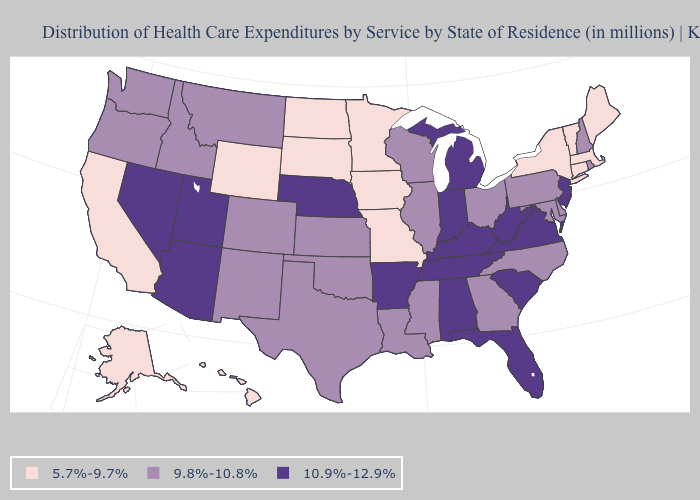What is the lowest value in states that border New Jersey?
Answer briefly. 5.7%-9.7%. Does Minnesota have the lowest value in the USA?
Write a very short answer. Yes. Which states have the lowest value in the USA?
Short answer required. Alaska, California, Connecticut, Hawaii, Iowa, Maine, Massachusetts, Minnesota, Missouri, New York, North Dakota, South Dakota, Vermont, Wyoming. What is the value of California?
Quick response, please. 5.7%-9.7%. Among the states that border New Mexico , which have the highest value?
Answer briefly. Arizona, Utah. Name the states that have a value in the range 10.9%-12.9%?
Quick response, please. Alabama, Arizona, Arkansas, Florida, Indiana, Kentucky, Michigan, Nebraska, Nevada, New Jersey, South Carolina, Tennessee, Utah, Virginia, West Virginia. Name the states that have a value in the range 5.7%-9.7%?
Answer briefly. Alaska, California, Connecticut, Hawaii, Iowa, Maine, Massachusetts, Minnesota, Missouri, New York, North Dakota, South Dakota, Vermont, Wyoming. Does Washington have the same value as Michigan?
Quick response, please. No. What is the value of Rhode Island?
Give a very brief answer. 9.8%-10.8%. What is the value of Georgia?
Short answer required. 9.8%-10.8%. What is the highest value in the MidWest ?
Be succinct. 10.9%-12.9%. What is the value of Wyoming?
Write a very short answer. 5.7%-9.7%. What is the value of Maine?
Short answer required. 5.7%-9.7%. Does the first symbol in the legend represent the smallest category?
Quick response, please. Yes. Name the states that have a value in the range 10.9%-12.9%?
Keep it brief. Alabama, Arizona, Arkansas, Florida, Indiana, Kentucky, Michigan, Nebraska, Nevada, New Jersey, South Carolina, Tennessee, Utah, Virginia, West Virginia. 